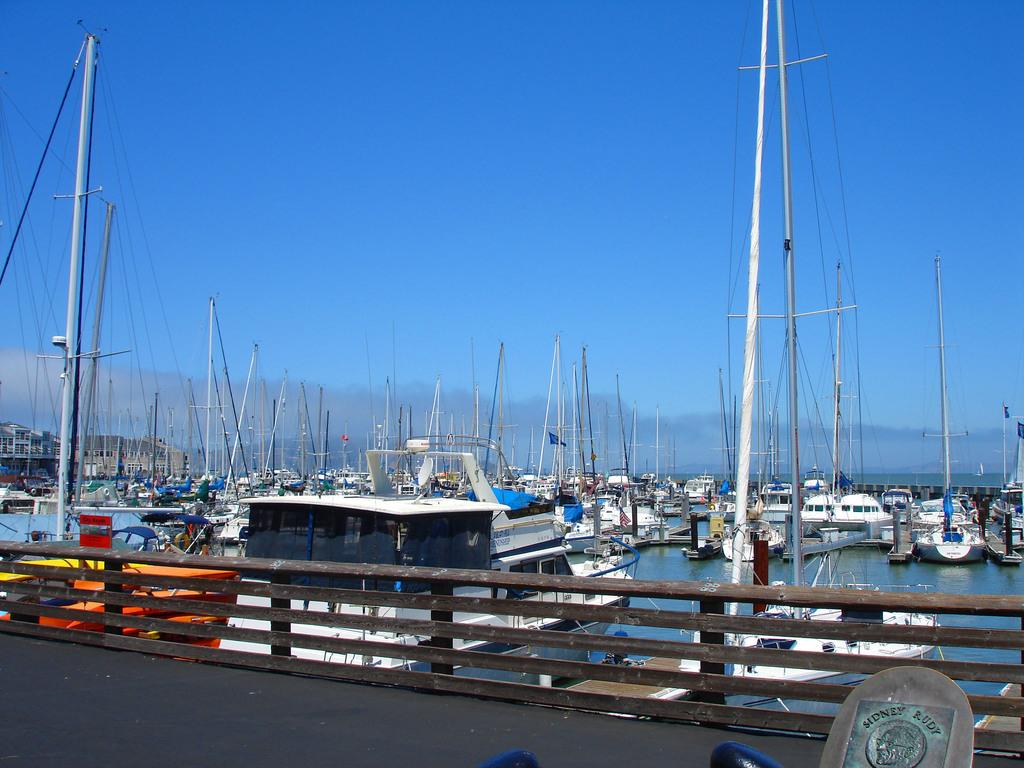What type of vehicles can be seen in the image? There are boats in the image. Where are the boats located? The boats are parked at a shipyard. What can be observed about the appearance of the boats? The boats are in different colors. What is visible in the background of the image? There are clouds in the background of the image. What is the color of the sky in the image? The sky is blue in the image. Can you see any houses or chickens in the image? No, there are no houses or chickens present in the image. Is there a bee buzzing around the boats in the image? There is no bee visible in the image. 